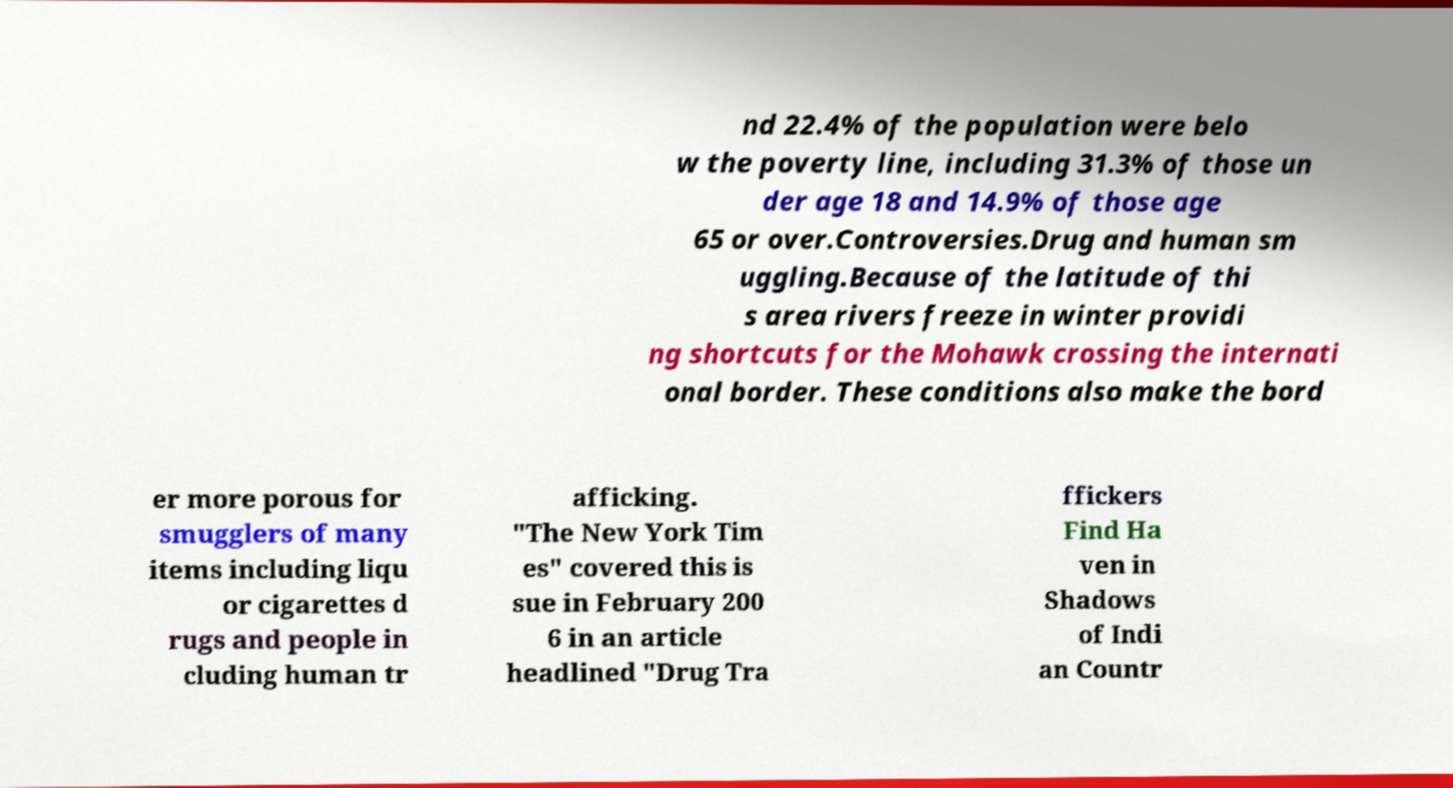There's text embedded in this image that I need extracted. Can you transcribe it verbatim? nd 22.4% of the population were belo w the poverty line, including 31.3% of those un der age 18 and 14.9% of those age 65 or over.Controversies.Drug and human sm uggling.Because of the latitude of thi s area rivers freeze in winter providi ng shortcuts for the Mohawk crossing the internati onal border. These conditions also make the bord er more porous for smugglers of many items including liqu or cigarettes d rugs and people in cluding human tr afficking. "The New York Tim es" covered this is sue in February 200 6 in an article headlined "Drug Tra ffickers Find Ha ven in Shadows of Indi an Countr 